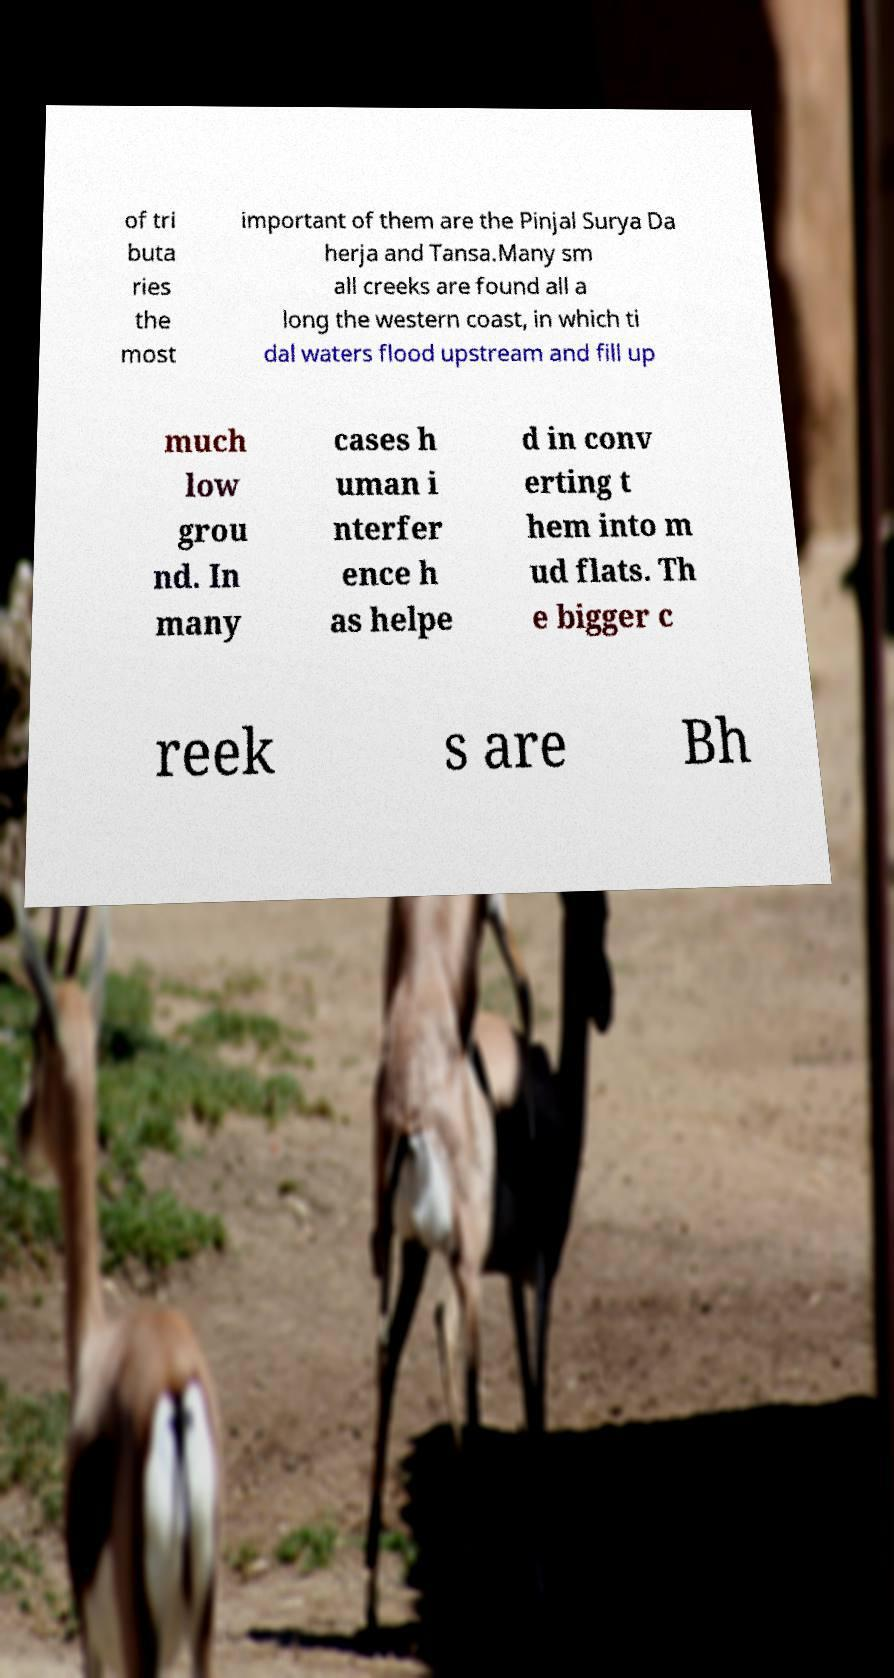There's text embedded in this image that I need extracted. Can you transcribe it verbatim? of tri buta ries the most important of them are the Pinjal Surya Da herja and Tansa.Many sm all creeks are found all a long the western coast, in which ti dal waters flood upstream and fill up much low grou nd. In many cases h uman i nterfer ence h as helpe d in conv erting t hem into m ud flats. Th e bigger c reek s are Bh 